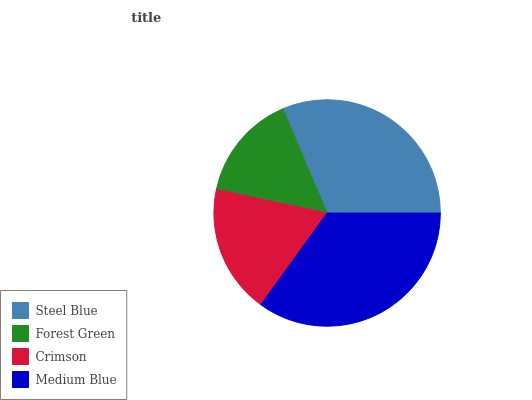Is Forest Green the minimum?
Answer yes or no. Yes. Is Medium Blue the maximum?
Answer yes or no. Yes. Is Crimson the minimum?
Answer yes or no. No. Is Crimson the maximum?
Answer yes or no. No. Is Crimson greater than Forest Green?
Answer yes or no. Yes. Is Forest Green less than Crimson?
Answer yes or no. Yes. Is Forest Green greater than Crimson?
Answer yes or no. No. Is Crimson less than Forest Green?
Answer yes or no. No. Is Steel Blue the high median?
Answer yes or no. Yes. Is Crimson the low median?
Answer yes or no. Yes. Is Crimson the high median?
Answer yes or no. No. Is Medium Blue the low median?
Answer yes or no. No. 